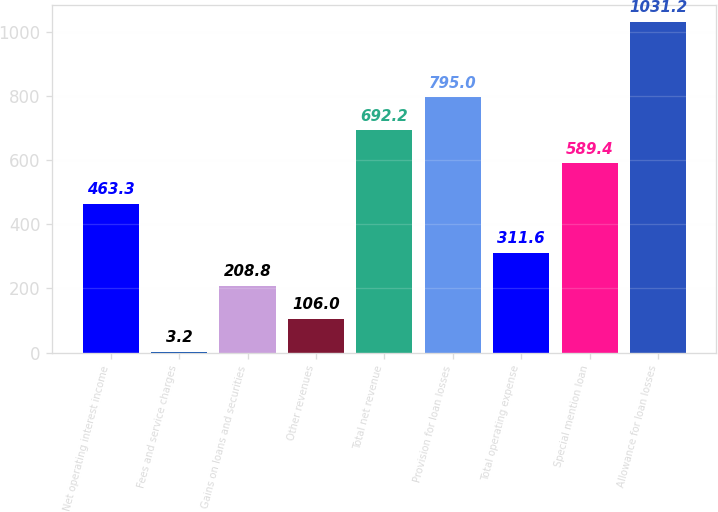Convert chart. <chart><loc_0><loc_0><loc_500><loc_500><bar_chart><fcel>Net operating interest income<fcel>Fees and service charges<fcel>Gains on loans and securities<fcel>Other revenues<fcel>Total net revenue<fcel>Provision for loan losses<fcel>Total operating expense<fcel>Special mention loan<fcel>Allowance for loan losses<nl><fcel>463.3<fcel>3.2<fcel>208.8<fcel>106<fcel>692.2<fcel>795<fcel>311.6<fcel>589.4<fcel>1031.2<nl></chart> 